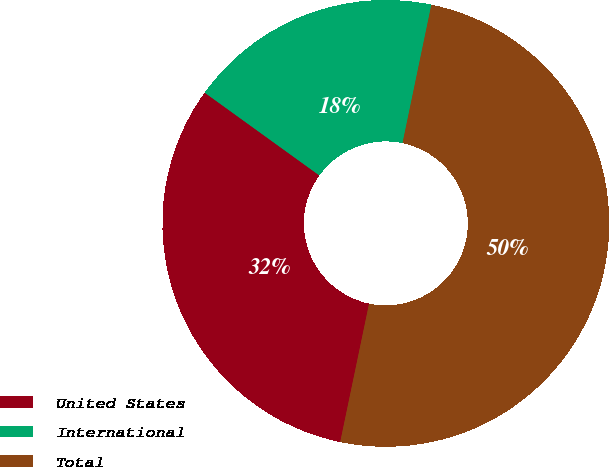Convert chart. <chart><loc_0><loc_0><loc_500><loc_500><pie_chart><fcel>United States<fcel>International<fcel>Total<nl><fcel>31.68%<fcel>18.32%<fcel>50.0%<nl></chart> 